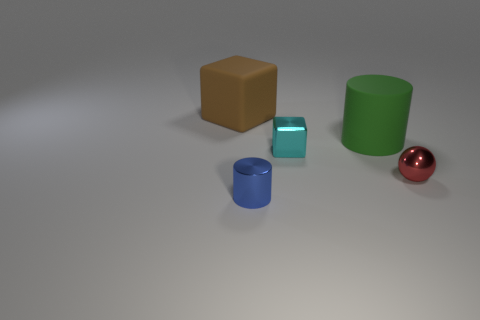Add 4 green metallic cylinders. How many objects exist? 9 Subtract all blocks. How many objects are left? 3 Add 2 small cyan shiny objects. How many small cyan shiny objects are left? 3 Add 1 cyan matte spheres. How many cyan matte spheres exist? 1 Subtract 0 gray spheres. How many objects are left? 5 Subtract all large green cylinders. Subtract all large things. How many objects are left? 2 